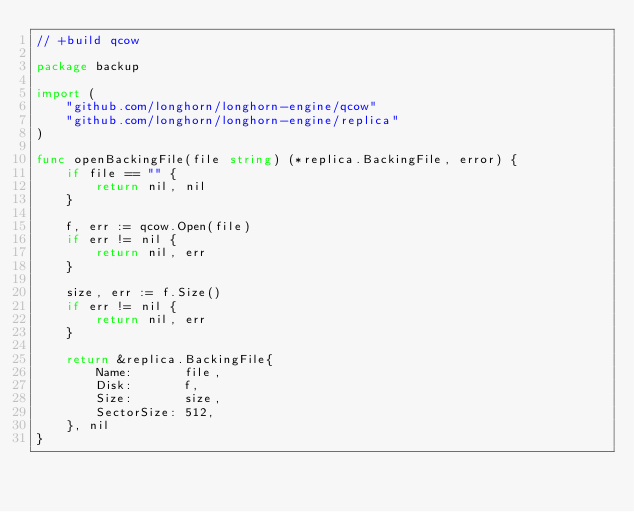Convert code to text. <code><loc_0><loc_0><loc_500><loc_500><_Go_>// +build qcow

package backup

import (
	"github.com/longhorn/longhorn-engine/qcow"
	"github.com/longhorn/longhorn-engine/replica"
)

func openBackingFile(file string) (*replica.BackingFile, error) {
	if file == "" {
		return nil, nil
	}

	f, err := qcow.Open(file)
	if err != nil {
		return nil, err
	}

	size, err := f.Size()
	if err != nil {
		return nil, err
	}

	return &replica.BackingFile{
		Name:       file,
		Disk:       f,
		Size:       size,
		SectorSize: 512,
	}, nil
}
</code> 